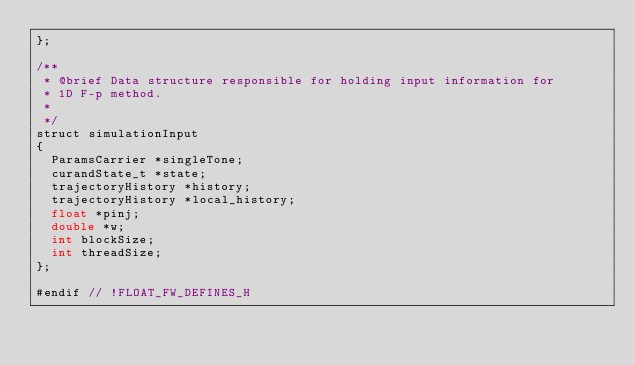<code> <loc_0><loc_0><loc_500><loc_500><_Cuda_>};

/**
 * @brief Data structure responsible for holding input information for 
 * 1D F-p method.
 * 
 */
struct simulationInput
{
	ParamsCarrier *singleTone;
	curandState_t *state;
	trajectoryHistory *history;
	trajectoryHistory *local_history;
	float *pinj;
	double *w;
	int blockSize;
	int threadSize;
};

#endif // !FLOAT_FW_DEFINES_H
</code> 